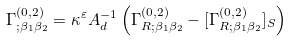<formula> <loc_0><loc_0><loc_500><loc_500>\Gamma ^ { ( 0 , 2 ) } _ { ; \beta _ { 1 } \beta _ { 2 } } = \kappa ^ { \varepsilon } A _ { d } ^ { - 1 } \left ( \Gamma ^ { ( 0 , 2 ) } _ { R ; \beta _ { 1 } \beta _ { 2 } } - [ \Gamma ^ { ( 0 , 2 ) } _ { R ; \beta _ { 1 } \beta _ { 2 } } ] _ { S } \right )</formula> 